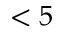Convert formula to latex. <formula><loc_0><loc_0><loc_500><loc_500>< 5</formula> 